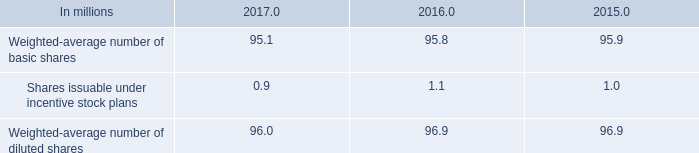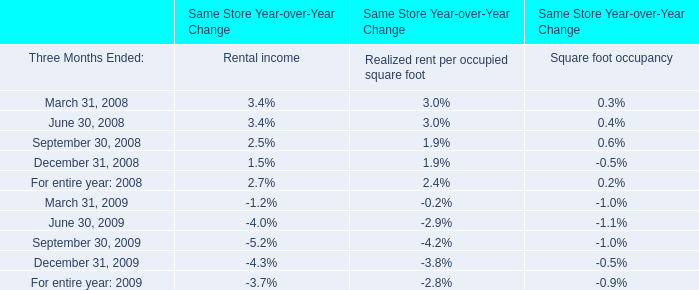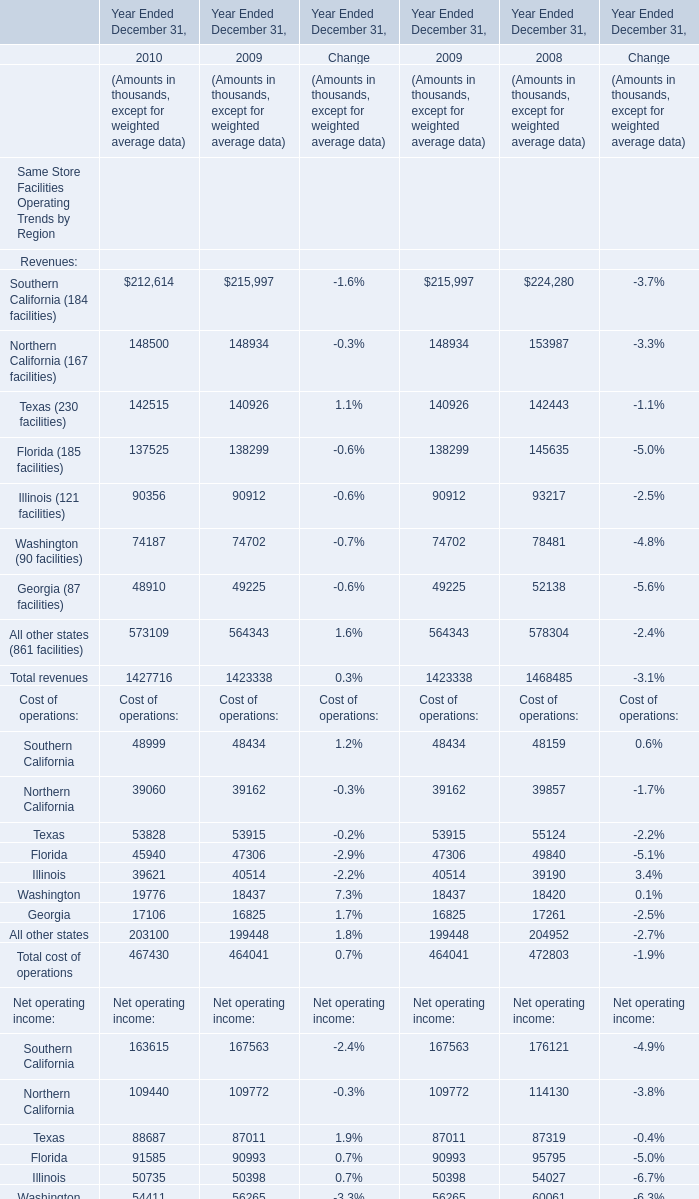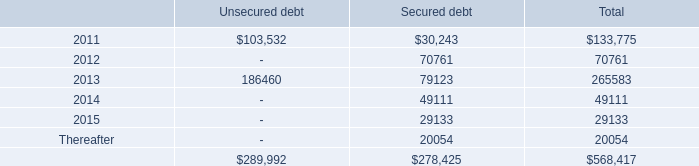What's the growth rate of Texas (230 facilities) in 2010? 
Computations: ((142515 - 140926) / 140926)
Answer: 0.01128. 